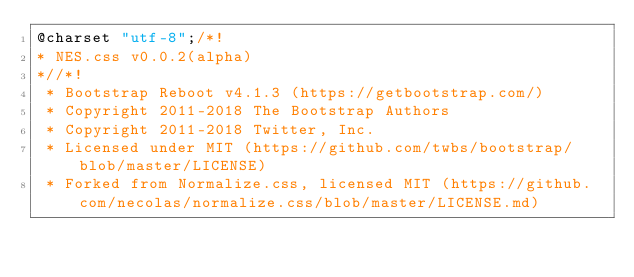<code> <loc_0><loc_0><loc_500><loc_500><_CSS_>@charset "utf-8";/*!
* NES.css v0.0.2(alpha)
*//*!
 * Bootstrap Reboot v4.1.3 (https://getbootstrap.com/)
 * Copyright 2011-2018 The Bootstrap Authors
 * Copyright 2011-2018 Twitter, Inc.
 * Licensed under MIT (https://github.com/twbs/bootstrap/blob/master/LICENSE)
 * Forked from Normalize.css, licensed MIT (https://github.com/necolas/normalize.css/blob/master/LICENSE.md)</code> 